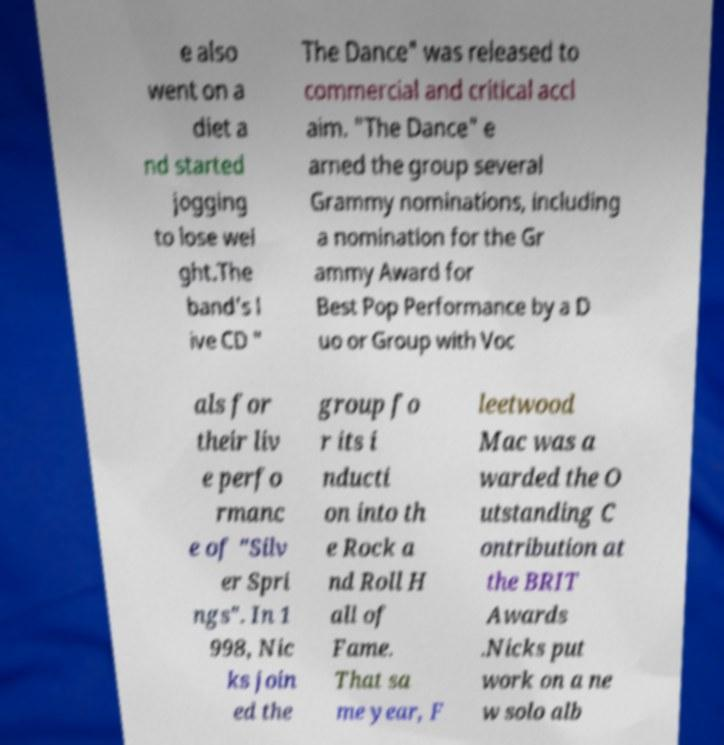Can you read and provide the text displayed in the image?This photo seems to have some interesting text. Can you extract and type it out for me? e also went on a diet a nd started jogging to lose wei ght.The band's l ive CD " The Dance" was released to commercial and critical accl aim. "The Dance" e arned the group several Grammy nominations, including a nomination for the Gr ammy Award for Best Pop Performance by a D uo or Group with Voc als for their liv e perfo rmanc e of "Silv er Spri ngs". In 1 998, Nic ks join ed the group fo r its i nducti on into th e Rock a nd Roll H all of Fame. That sa me year, F leetwood Mac was a warded the O utstanding C ontribution at the BRIT Awards .Nicks put work on a ne w solo alb 